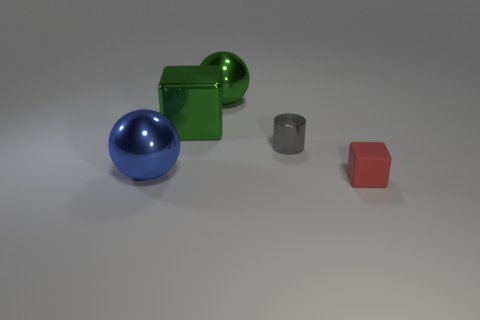What number of other objects are the same color as the big cube?
Ensure brevity in your answer.  1. How many things are either things that are left of the red rubber object or tiny blue metallic balls?
Offer a very short reply. 4. There is a small object that is the same material as the big green ball; what is its shape?
Your answer should be compact. Cylinder. Is there anything else that has the same shape as the tiny metallic thing?
Your answer should be compact. No. There is a object that is both to the right of the big green metallic sphere and behind the small red object; what is its color?
Offer a terse response. Gray. What number of spheres are either large metallic things or red objects?
Your response must be concise. 2. What number of other green blocks are the same size as the green cube?
Your answer should be very brief. 0. How many spheres are on the left side of the cube left of the gray thing?
Keep it short and to the point. 1. There is a thing that is left of the green metal sphere and on the right side of the big blue shiny thing; how big is it?
Make the answer very short. Large. Are there more big green things than metal things?
Your answer should be very brief. No. 